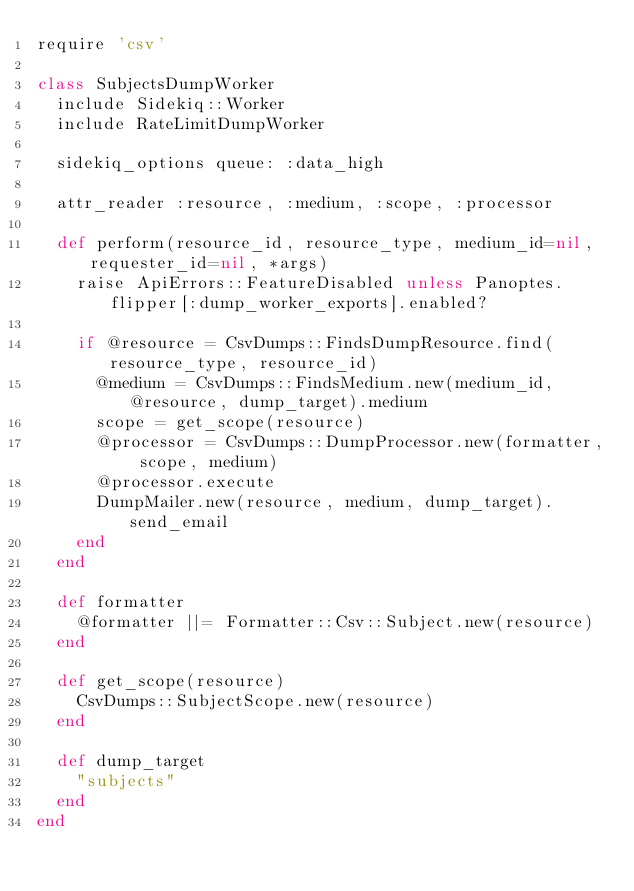<code> <loc_0><loc_0><loc_500><loc_500><_Ruby_>require 'csv'

class SubjectsDumpWorker
  include Sidekiq::Worker
  include RateLimitDumpWorker

  sidekiq_options queue: :data_high

  attr_reader :resource, :medium, :scope, :processor

  def perform(resource_id, resource_type, medium_id=nil, requester_id=nil, *args)
    raise ApiErrors::FeatureDisabled unless Panoptes.flipper[:dump_worker_exports].enabled?

    if @resource = CsvDumps::FindsDumpResource.find(resource_type, resource_id)
      @medium = CsvDumps::FindsMedium.new(medium_id, @resource, dump_target).medium
      scope = get_scope(resource)
      @processor = CsvDumps::DumpProcessor.new(formatter, scope, medium)
      @processor.execute
      DumpMailer.new(resource, medium, dump_target).send_email
    end
  end

  def formatter
    @formatter ||= Formatter::Csv::Subject.new(resource)
  end

  def get_scope(resource)
    CsvDumps::SubjectScope.new(resource)
  end

  def dump_target
    "subjects"
  end
end
</code> 